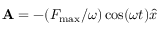<formula> <loc_0><loc_0><loc_500><loc_500>{ A } = - ( { F _ { \max } } / { \omega } ) \cos ( \omega t ) \hat { x }</formula> 